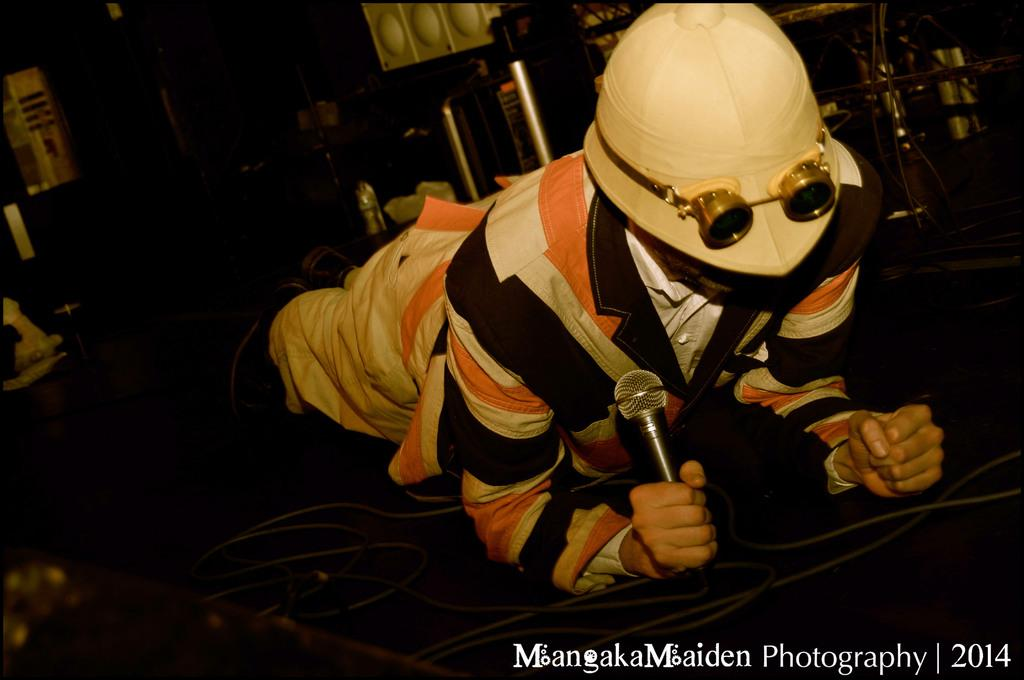What can be seen in the image? There is a person in the image. What is the person wearing? The person is wearing a helmet. What is the person holding in his hand? The person is holding a mic in his hand. What type of pet can be seen in the image? There is no pet present in the image. What type of prose is being recited by the person in the image? There is no indication of any prose being recited in the image. 